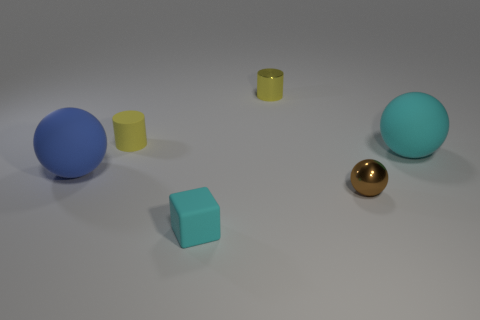There is a big rubber object that is behind the large matte thing that is in front of the big matte sphere right of the small cyan block; what shape is it?
Provide a short and direct response. Sphere. Do the brown ball that is in front of the blue matte ball and the sphere on the left side of the small yellow metal object have the same material?
Offer a terse response. No. There is a small yellow thing that is the same material as the tiny brown sphere; what shape is it?
Keep it short and to the point. Cylinder. Is there anything else that has the same color as the cube?
Offer a terse response. Yes. What number of rubber things are there?
Make the answer very short. 4. There is a small brown thing to the right of the cylinder that is to the left of the cyan cube; what is it made of?
Provide a succinct answer. Metal. There is a large sphere that is in front of the large object that is on the right side of the yellow cylinder that is on the right side of the small yellow rubber cylinder; what color is it?
Keep it short and to the point. Blue. Do the rubber cylinder and the metallic cylinder have the same color?
Your response must be concise. Yes. What number of cyan rubber cylinders are the same size as the brown thing?
Keep it short and to the point. 0. Are there more tiny yellow matte things that are behind the tiny shiny sphere than small metallic balls that are in front of the cyan rubber cube?
Offer a terse response. Yes. 